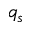Convert formula to latex. <formula><loc_0><loc_0><loc_500><loc_500>q _ { s }</formula> 